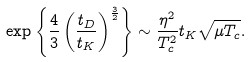<formula> <loc_0><loc_0><loc_500><loc_500>\exp { \left \{ { \frac { 4 } { 3 } } \left ( { \frac { t _ { D } } { t _ { K } } } \right ) ^ { \frac { 3 } { 2 } } \right \} } \sim { \frac { \eta ^ { 2 } } { T _ { c } ^ { 2 } } } t _ { K } \sqrt { \mu T _ { c } } .</formula> 